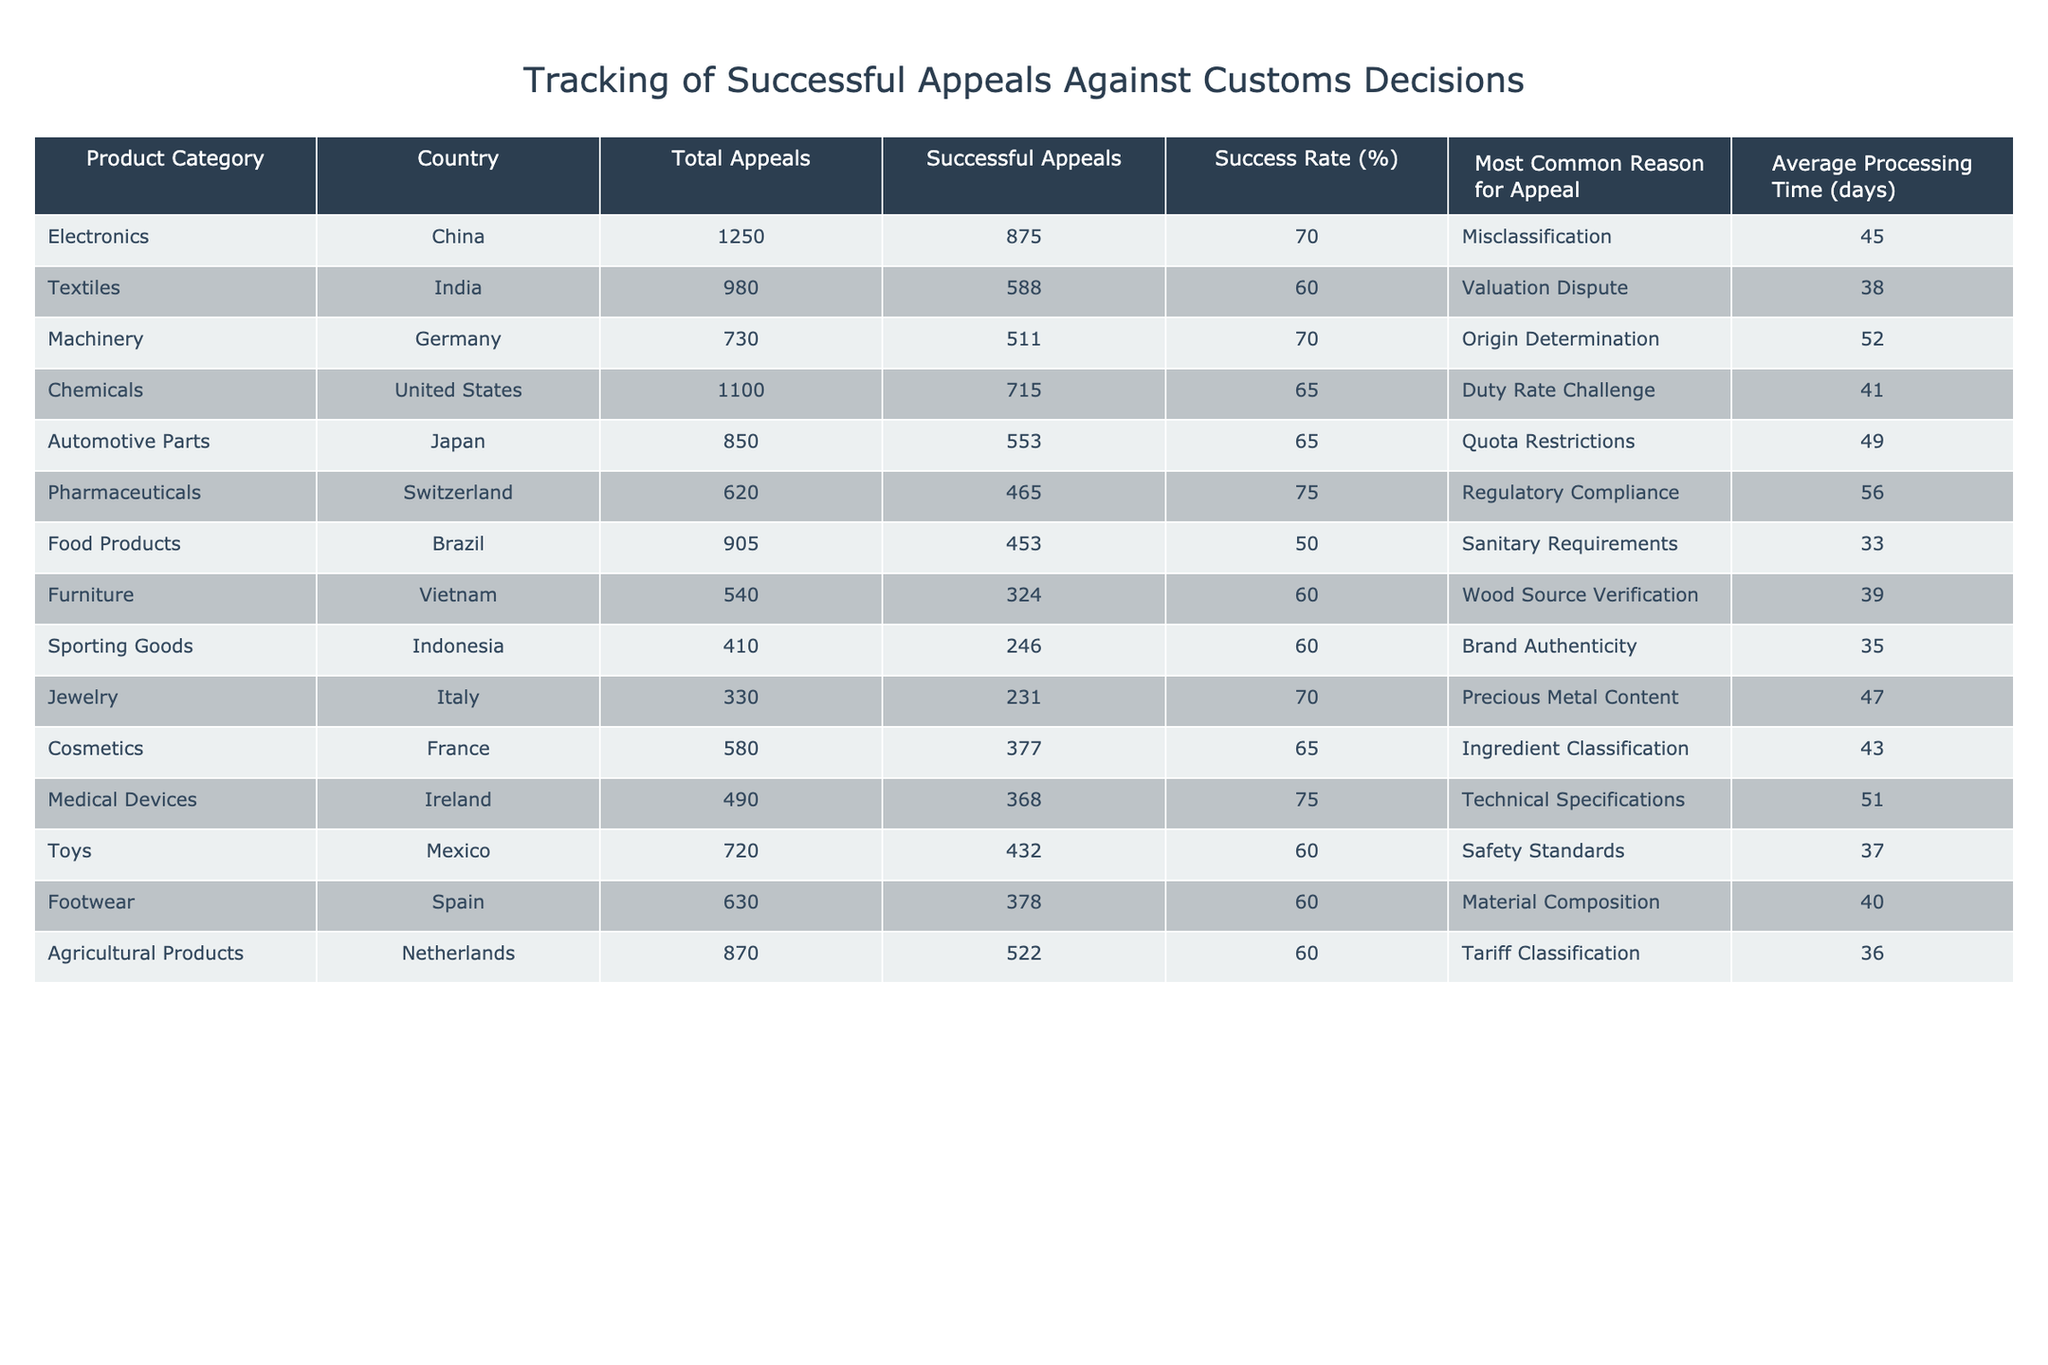What is the success rate of appeals for Electronics from China? The success rate for Electronics in China is directly provided in the table, listed under "Success Rate (%)". The value for China in the Electronics category is 70%.
Answer: 70% Which country has the highest number of total appeals? From the "Total Appeals" column, China has the highest count with 1250 total appeals, compared to other countries listed.
Answer: China How many successful appeals were made for Automotive Parts in Japan? The "Successful Appeals" column for Japan's Automotive Parts shows a value of 553 successful appeals. This is a direct retrieval of the value from the table.
Answer: 553 What is the average processing time for successful appeals in the Pharmaceuticals category? The average processing time for Pharmaceuticals is found in the "Average Processing Time (days)" column. The value is 56 days when directly referenced from the table.
Answer: 56 Is the success rate for Food Products in Brazil higher than 55%? The success rate for Food Products in Brazil is listed as 50% in the table, which is lower than 55%. Thus, the statement is false.
Answer: No Which product category has the lowest success rate and what is that rate? Comparing the "Success Rate (%)" column, Food Products in Brazil has the lowest success rate at 50%. This is derived by checking all categories to find the minimum.
Answer: 50% What is the difference in successful appeals between Machinery in Germany and Chemicals in the United States? Successful appeals for Machinery in Germany total 511, while for Chemicals in the United States it is 715. Subtracting these values gives 715 - 511 = 204.
Answer: 204 Calculate the average success rate of the appeals across all product categories listed. By adding the success rates: (70 + 60 + 70 + 65 + 65 + 75 + 50 + 60 + 60 + 70 + 65 + 75 + 60 + 60 + 60) = 1005. There are 15 categories, so the average is 1005 / 15 = 67%.
Answer: 67% In which category does the most common reason for appeal involve "Misclassification" and what is the success rate for that category? The category with "Misclassification" as the most common reason is Electronics, which has a success rate of 70%. This is determined by identifying the product category and checking the corresponding success rate.
Answer: 70% How many days on average does it take to process an appeal for Sporting Goods from Indonesia? The average processing time for Sporting Goods in Indonesia is directly listed in the "Average Processing Time (days)" column. It shows the value as 35 days.
Answer: 35 